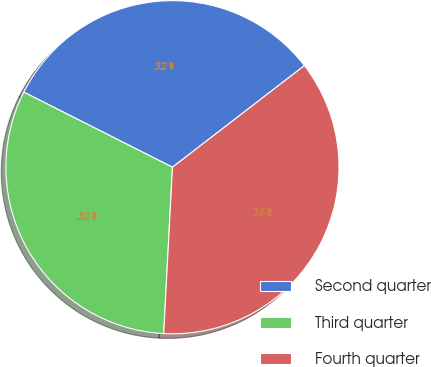<chart> <loc_0><loc_0><loc_500><loc_500><pie_chart><fcel>Second quarter<fcel>Third quarter<fcel>Fourth quarter<nl><fcel>32.11%<fcel>31.61%<fcel>36.28%<nl></chart> 